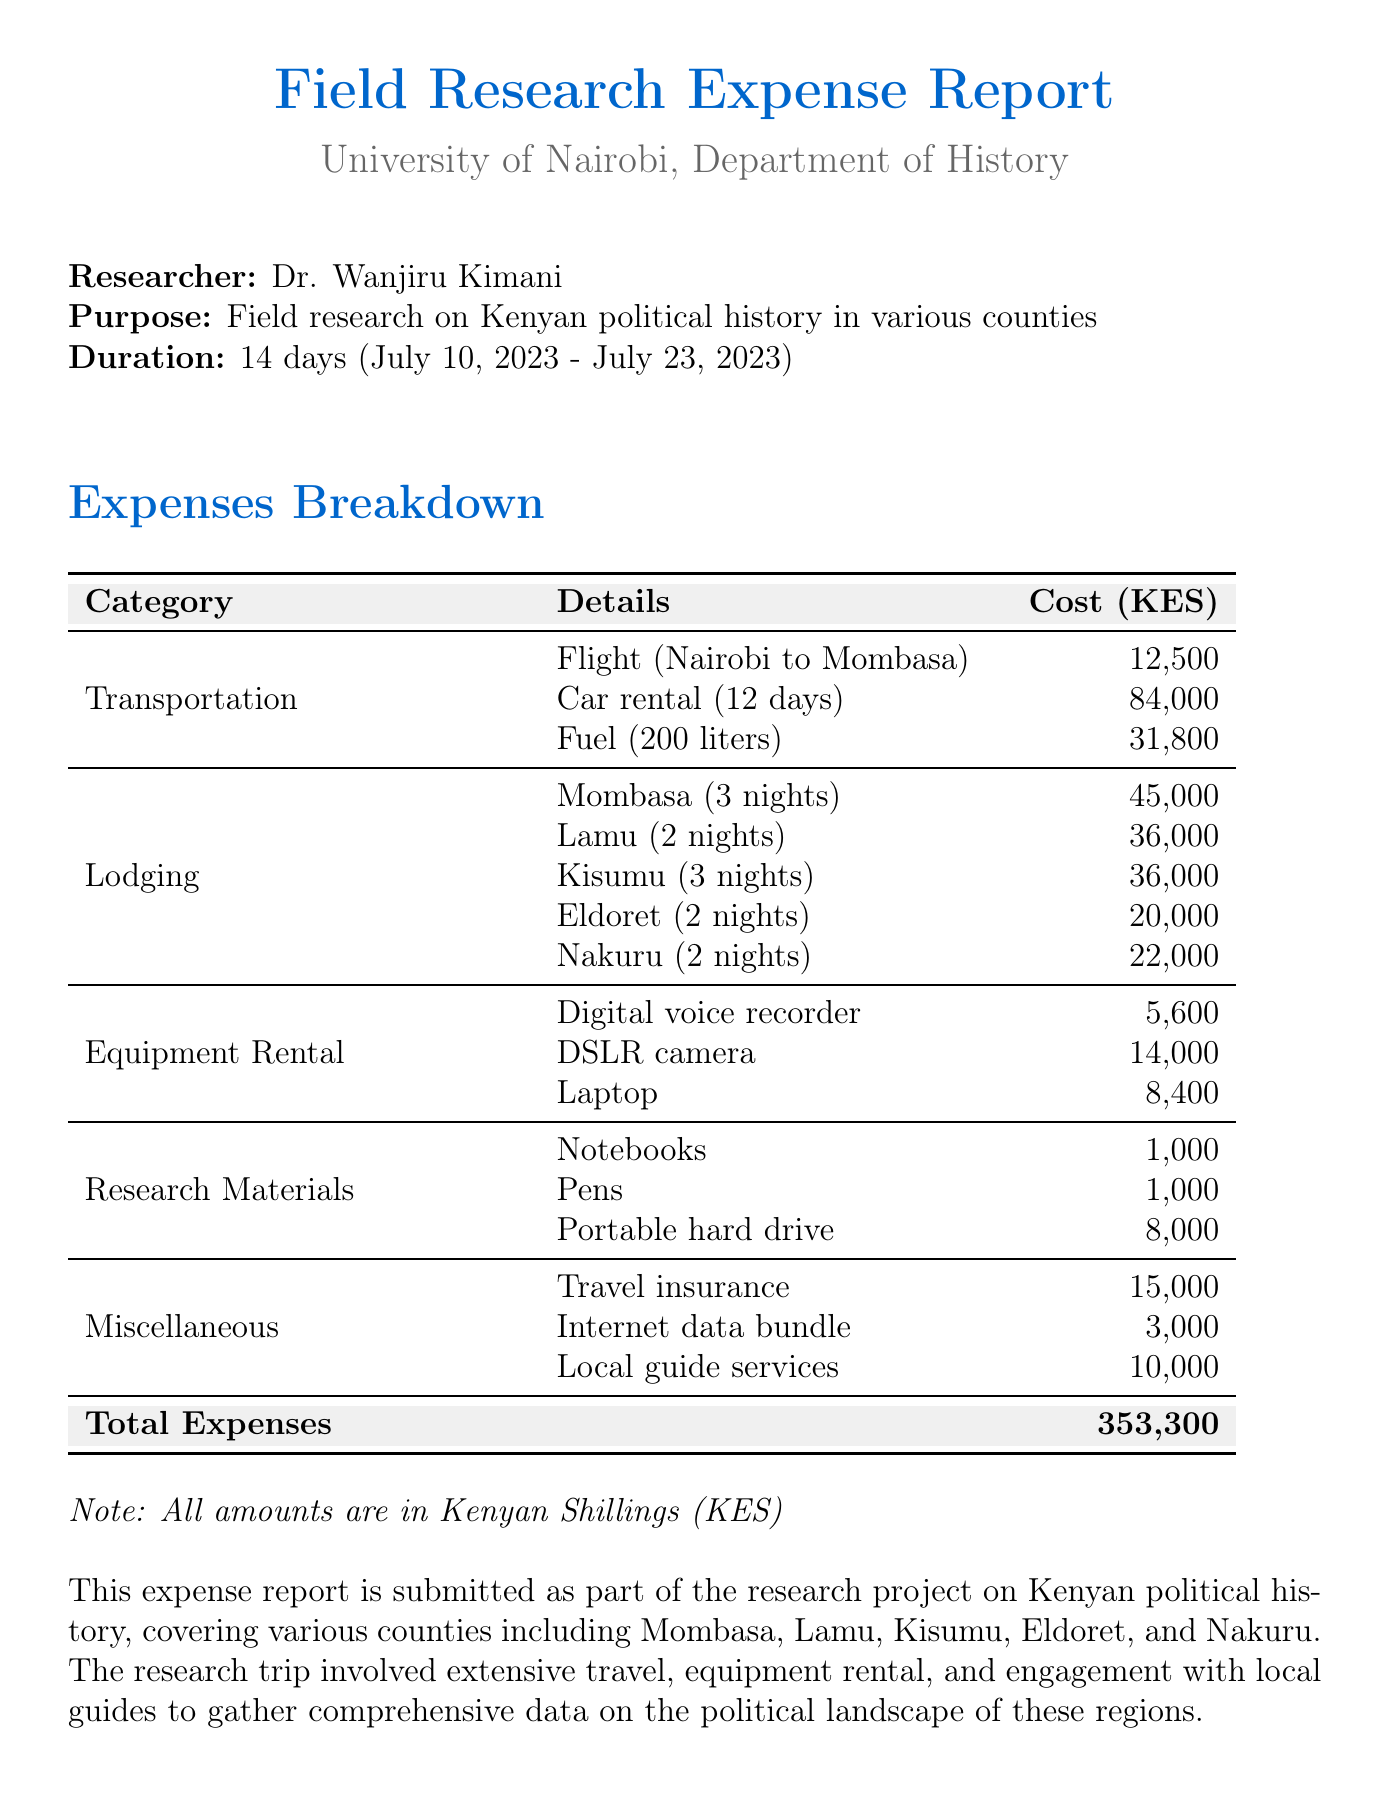What was the purpose of the trip? The purpose of the trip is stated in the document as field research on Kenyan political history in various counties.
Answer: Field research on Kenyan political history What is the total cost of lodging? The total cost of lodging is the sum of the individual lodging costs for each location listed in the document.
Answer: 180000 Who is the researcher? The document specifies the researcher for the trip.
Answer: Dr. Wanjiru Kimani How many nights did the researcher stay in Kisumu? The document provides the number of nights spent in Kisumu specifically.
Answer: 3 What was the cost of the DSLR camera rental? The document lists the cost associated with the rental of the DSLR camera.
Answer: 14000 Which insurance provider was used? The document mentions the provider for the travel insurance purchased.
Answer: APA Insurance What item had the highest individual cost in the transportation category? The highest individual cost can be found by comparing the costs listed under the transportation category in the document.
Answer: Car rental How many days were local guide services hired? The document states the number of days for which local guide services were hired.
Answer: 4 What is the duration of the field research trip? The duration of the trip is mentioned clearly in the document.
Answer: 14 days What is the total expense for the trip? The document sums all the expenses to provide a total expense value.
Answer: 353300 